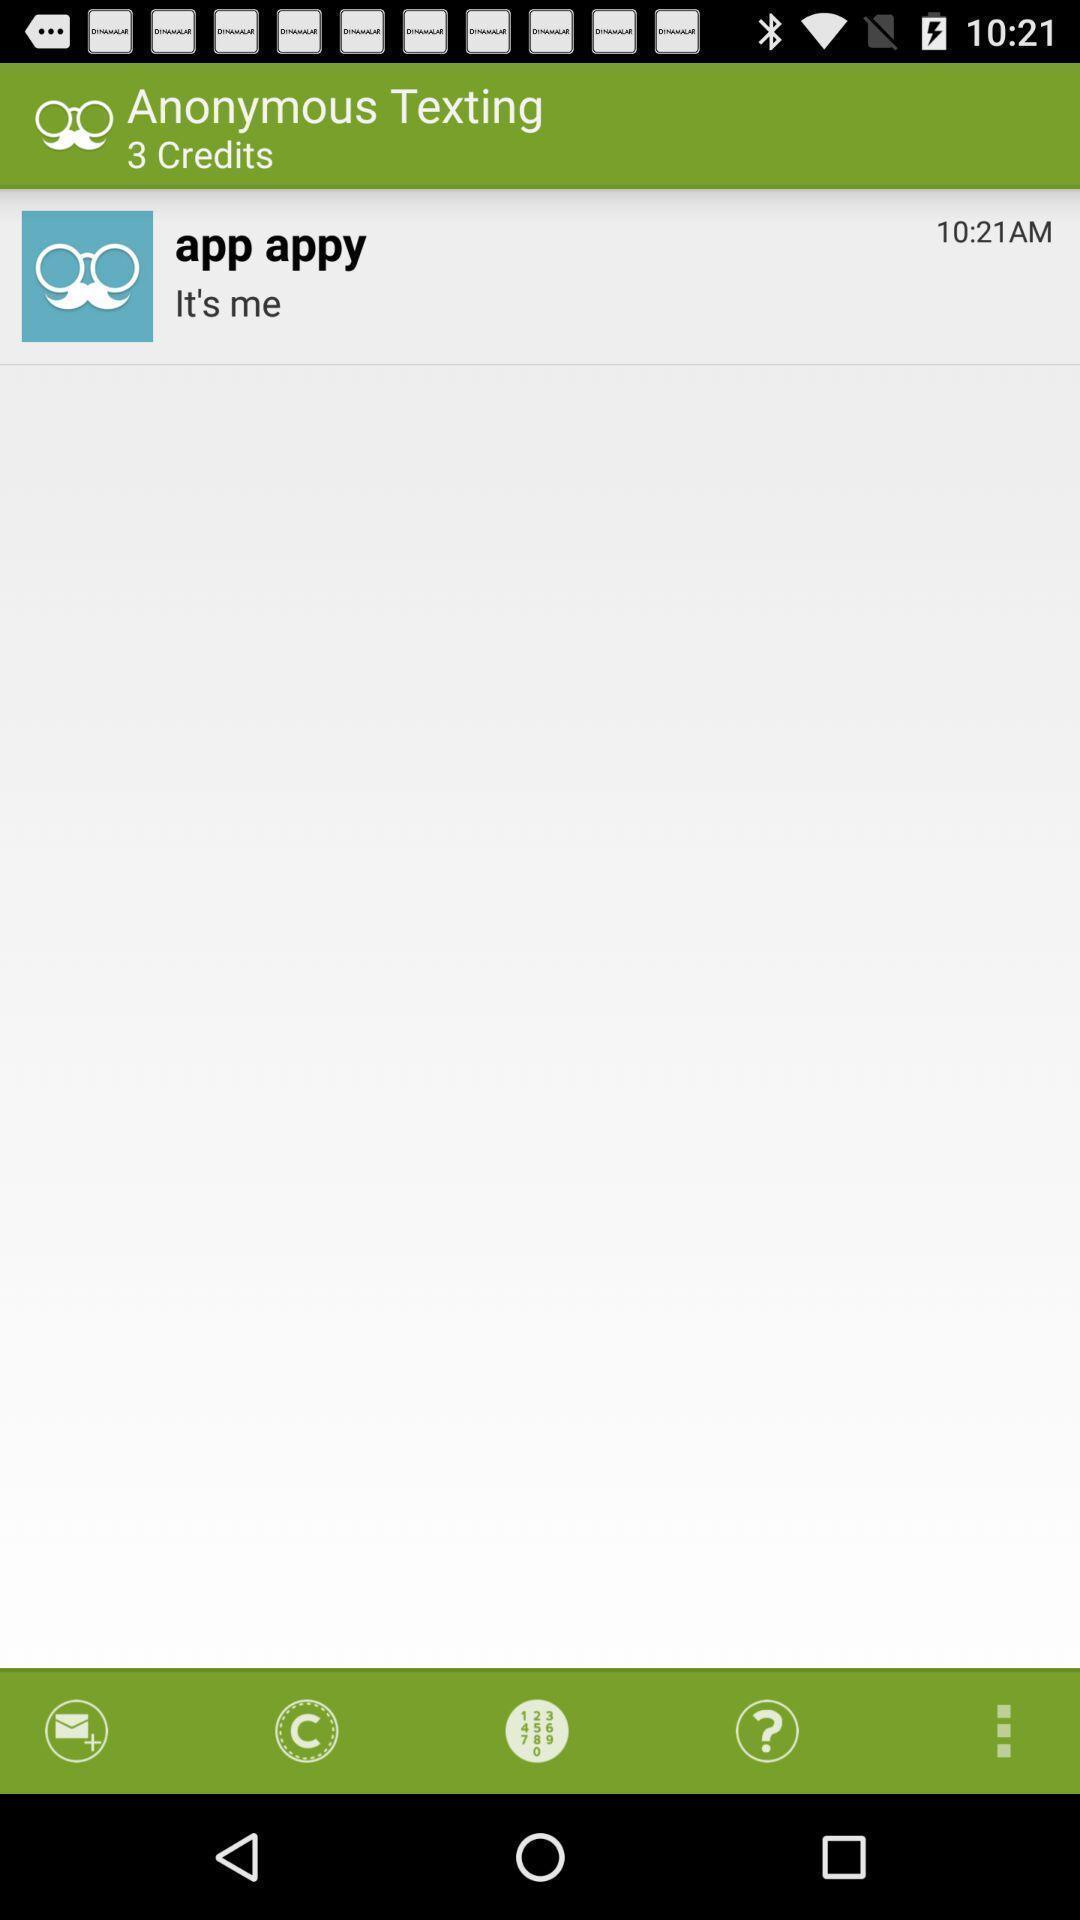Describe the key features of this screenshot. Page of an anonymous messaging app. 